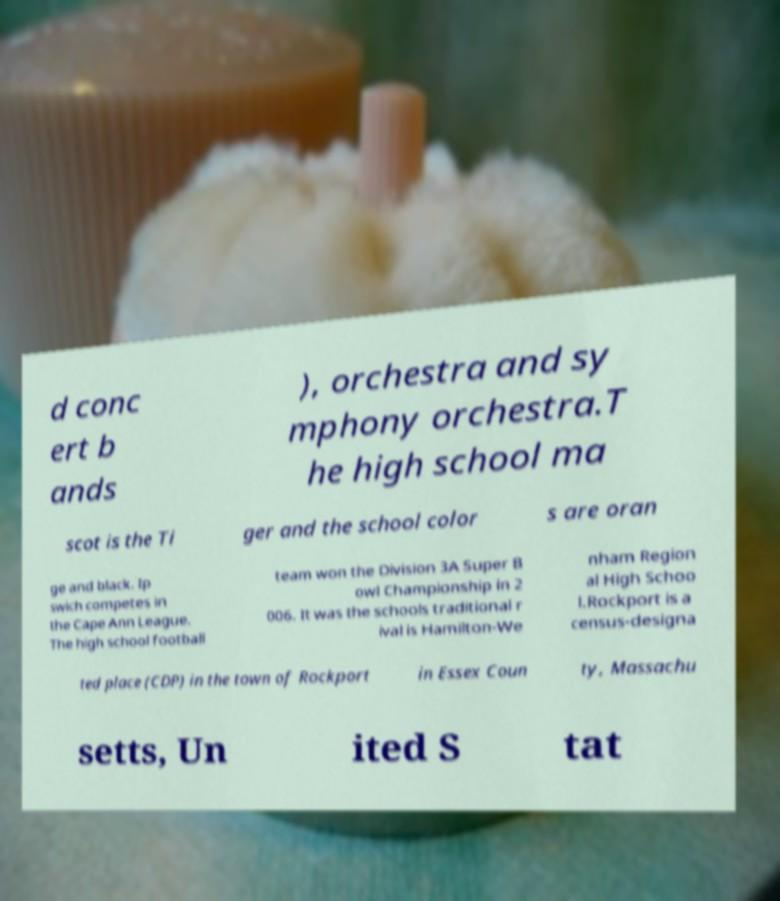There's text embedded in this image that I need extracted. Can you transcribe it verbatim? d conc ert b ands ), orchestra and sy mphony orchestra.T he high school ma scot is the Ti ger and the school color s are oran ge and black. Ip swich competes in the Cape Ann League. The high school football team won the Division 3A Super B owl Championship in 2 006. It was the schools traditional r ival is Hamilton-We nham Region al High Schoo l.Rockport is a census-designa ted place (CDP) in the town of Rockport in Essex Coun ty, Massachu setts, Un ited S tat 